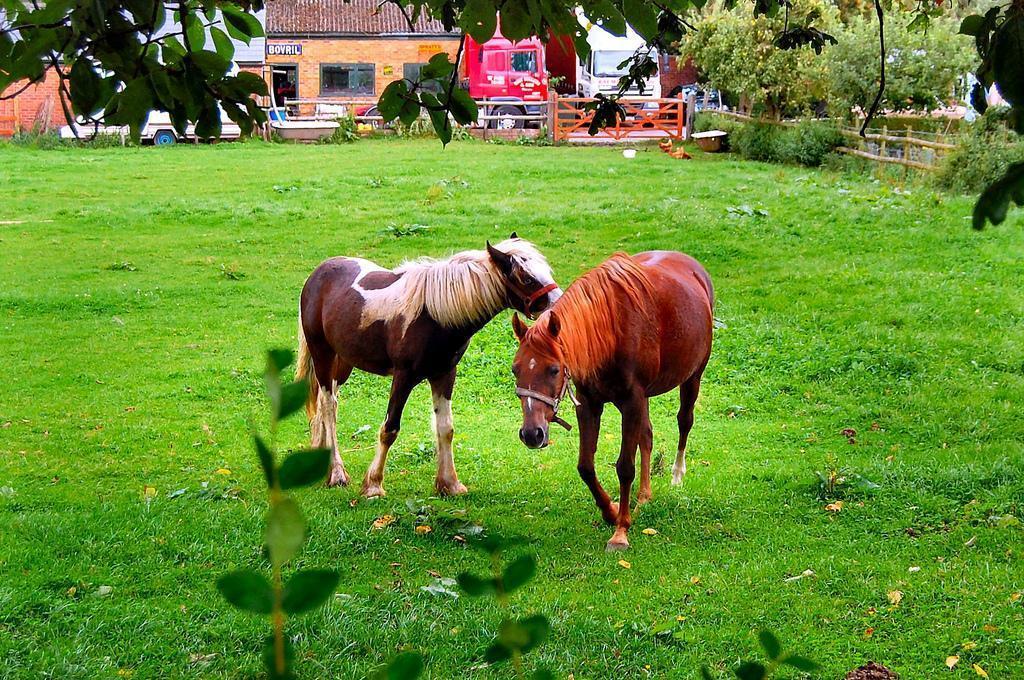How many horse are there?
Give a very brief answer. 2. How many animals are there?
Give a very brief answer. 2. How many colors is the horse with the white mane?
Give a very brief answer. 2. 